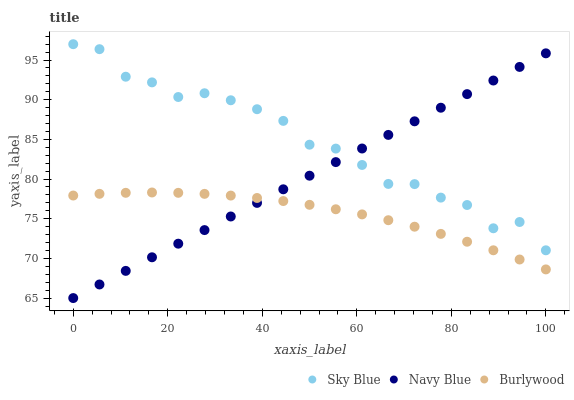Does Burlywood have the minimum area under the curve?
Answer yes or no. Yes. Does Sky Blue have the maximum area under the curve?
Answer yes or no. Yes. Does Navy Blue have the minimum area under the curve?
Answer yes or no. No. Does Navy Blue have the maximum area under the curve?
Answer yes or no. No. Is Navy Blue the smoothest?
Answer yes or no. Yes. Is Sky Blue the roughest?
Answer yes or no. Yes. Is Sky Blue the smoothest?
Answer yes or no. No. Is Navy Blue the roughest?
Answer yes or no. No. Does Navy Blue have the lowest value?
Answer yes or no. Yes. Does Sky Blue have the lowest value?
Answer yes or no. No. Does Sky Blue have the highest value?
Answer yes or no. Yes. Does Navy Blue have the highest value?
Answer yes or no. No. Is Burlywood less than Sky Blue?
Answer yes or no. Yes. Is Sky Blue greater than Burlywood?
Answer yes or no. Yes. Does Navy Blue intersect Sky Blue?
Answer yes or no. Yes. Is Navy Blue less than Sky Blue?
Answer yes or no. No. Is Navy Blue greater than Sky Blue?
Answer yes or no. No. Does Burlywood intersect Sky Blue?
Answer yes or no. No. 